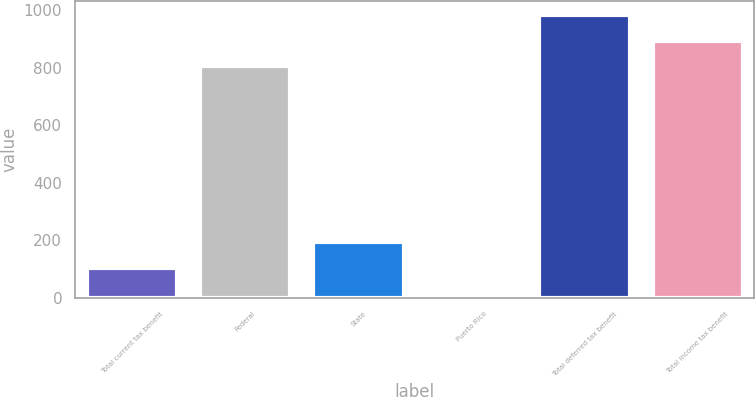<chart> <loc_0><loc_0><loc_500><loc_500><bar_chart><fcel>Total current tax benefit<fcel>Federal<fcel>State<fcel>Puerto Rico<fcel>Total deferred tax benefit<fcel>Total income tax benefit<nl><fcel>104<fcel>804<fcel>194<fcel>14<fcel>984<fcel>894<nl></chart> 